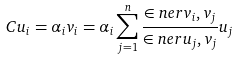Convert formula to latex. <formula><loc_0><loc_0><loc_500><loc_500>C u _ { i } = \alpha _ { i } v _ { i } = \alpha _ { i } \sum _ { j = 1 } ^ { n } \frac { \in n e r { v _ { i } , v _ { j } } } { \in n e r { u _ { j } , v _ { j } } } u _ { j }</formula> 